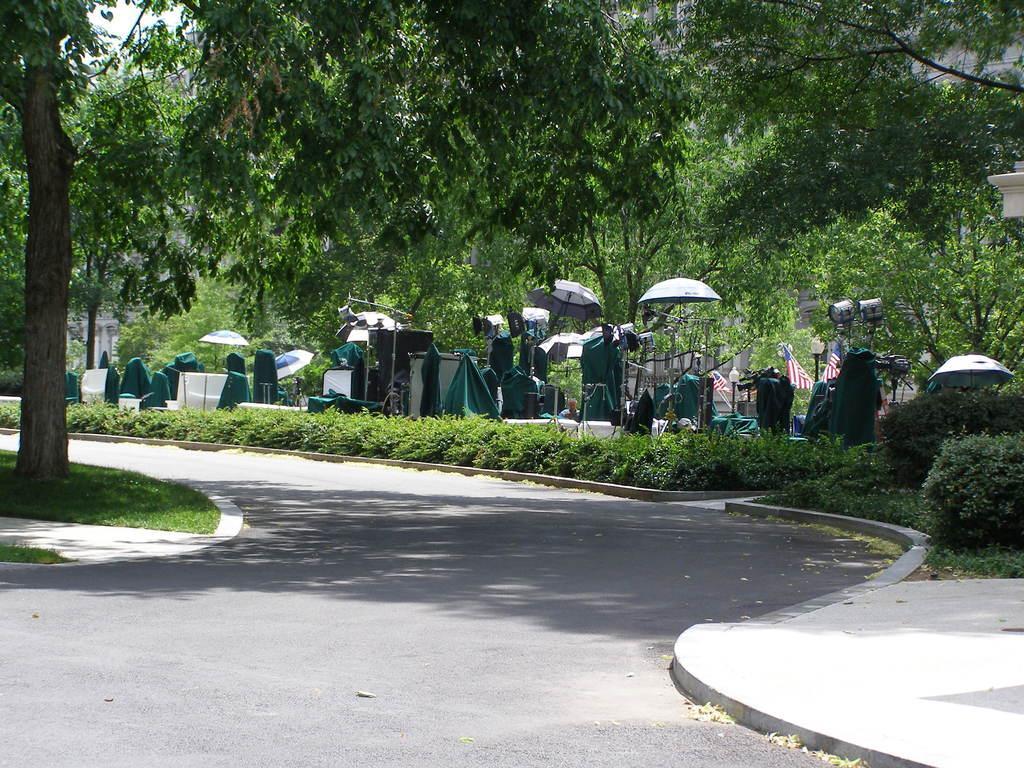Can you describe this image briefly? In this image we can see a road. Behind the road we can see few plants, umbrellas, green objects and group of trees. On the left side, we can see a tree and grass. On the top right, we can see a wall. In the top left, we can see the sky. 